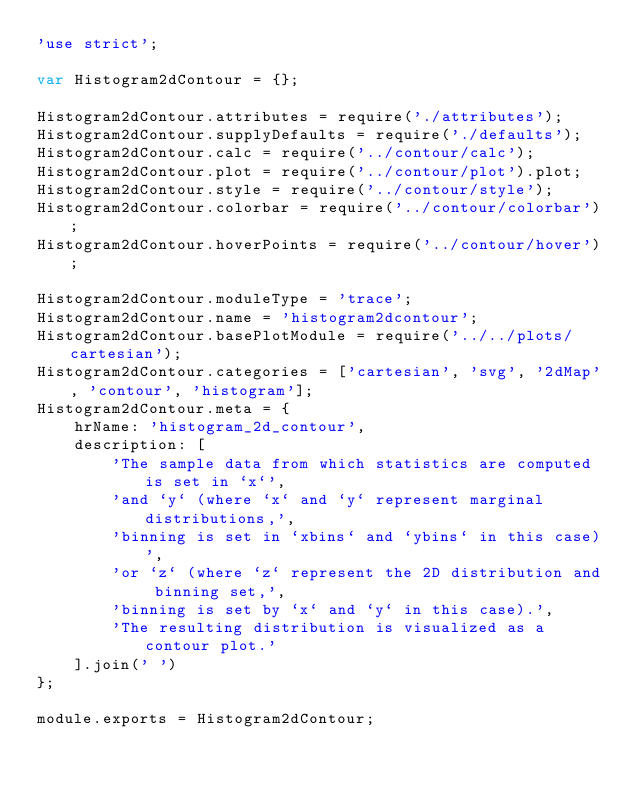<code> <loc_0><loc_0><loc_500><loc_500><_JavaScript_>'use strict';

var Histogram2dContour = {};

Histogram2dContour.attributes = require('./attributes');
Histogram2dContour.supplyDefaults = require('./defaults');
Histogram2dContour.calc = require('../contour/calc');
Histogram2dContour.plot = require('../contour/plot').plot;
Histogram2dContour.style = require('../contour/style');
Histogram2dContour.colorbar = require('../contour/colorbar');
Histogram2dContour.hoverPoints = require('../contour/hover');

Histogram2dContour.moduleType = 'trace';
Histogram2dContour.name = 'histogram2dcontour';
Histogram2dContour.basePlotModule = require('../../plots/cartesian');
Histogram2dContour.categories = ['cartesian', 'svg', '2dMap', 'contour', 'histogram'];
Histogram2dContour.meta = {
    hrName: 'histogram_2d_contour',
    description: [
        'The sample data from which statistics are computed is set in `x`',
        'and `y` (where `x` and `y` represent marginal distributions,',
        'binning is set in `xbins` and `ybins` in this case)',
        'or `z` (where `z` represent the 2D distribution and binning set,',
        'binning is set by `x` and `y` in this case).',
        'The resulting distribution is visualized as a contour plot.'
    ].join(' ')
};

module.exports = Histogram2dContour;
</code> 